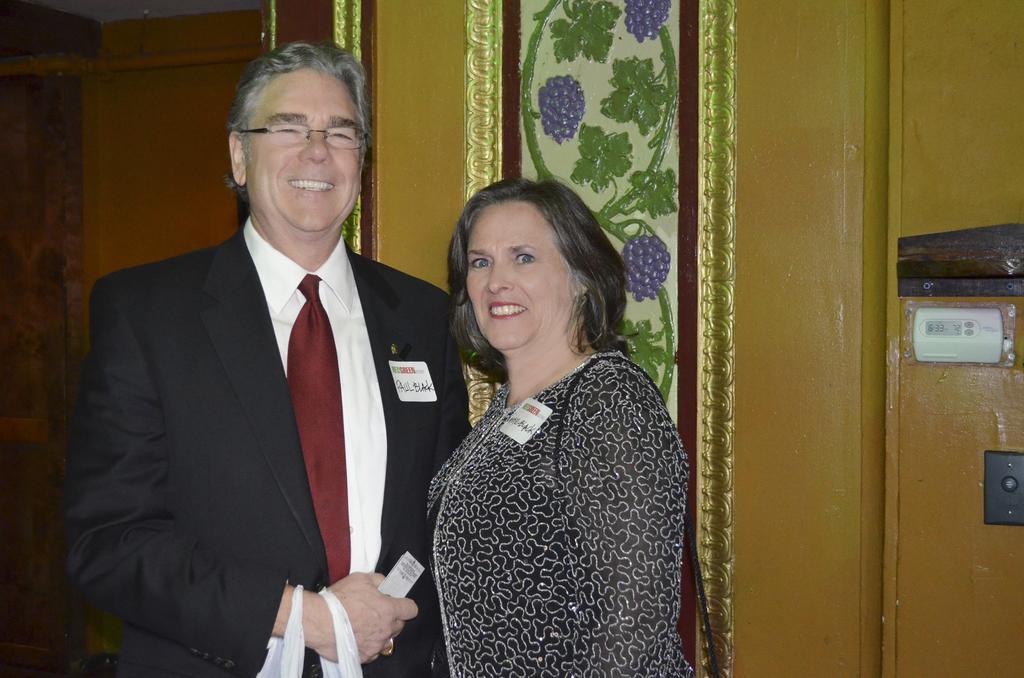Describe this image in one or two sentences. This picture shows a man and a woman standing. We see a man wore spectacles on his face and we see smile on their faces and we see badges to their clothes and we see man holding a carry bag. 